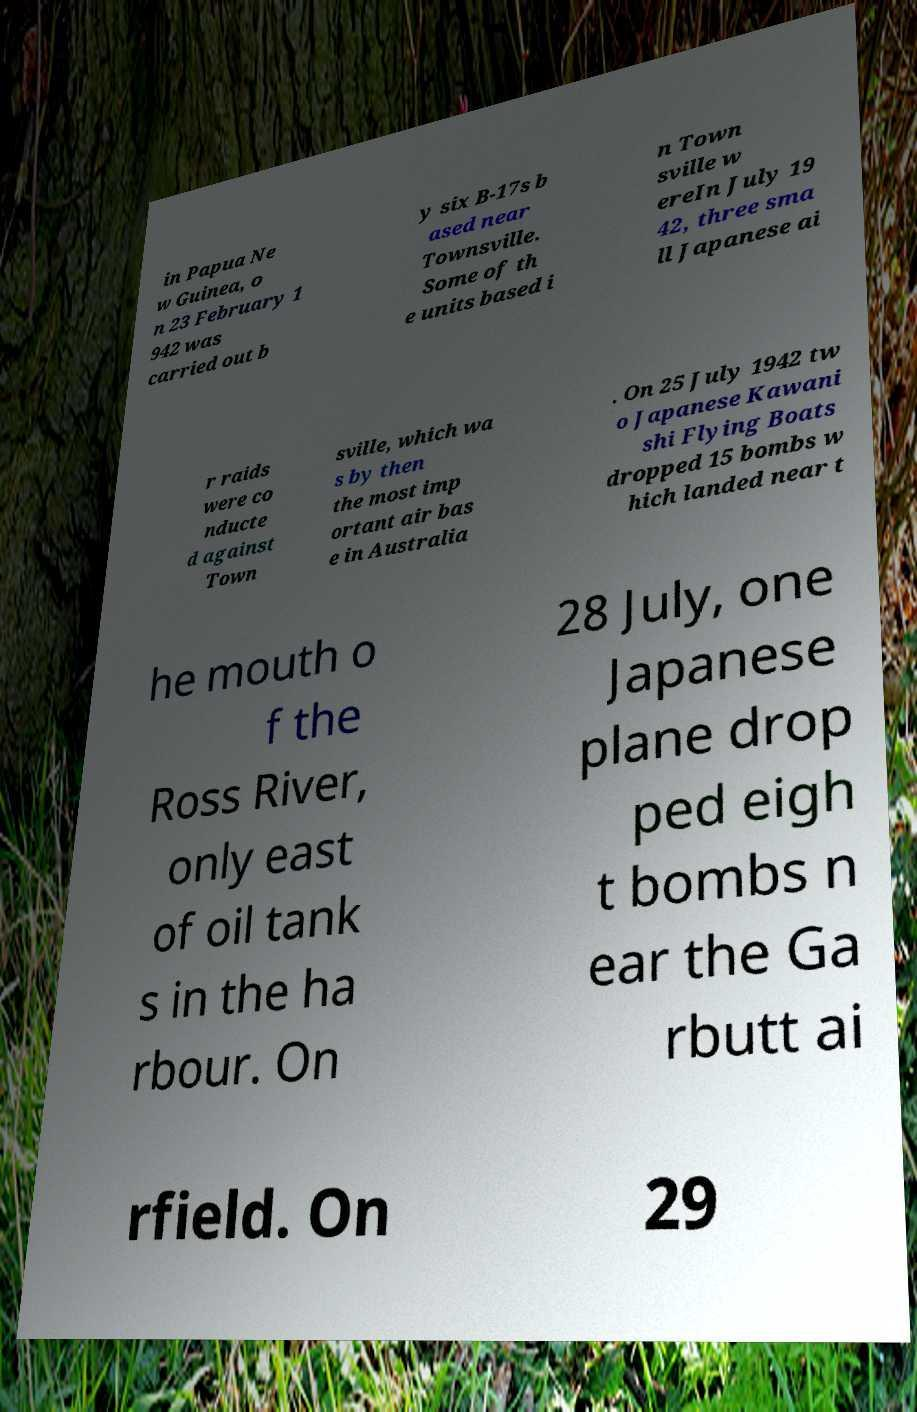Please identify and transcribe the text found in this image. in Papua Ne w Guinea, o n 23 February 1 942 was carried out b y six B-17s b ased near Townsville. Some of th e units based i n Town sville w ereIn July 19 42, three sma ll Japanese ai r raids were co nducte d against Town sville, which wa s by then the most imp ortant air bas e in Australia . On 25 July 1942 tw o Japanese Kawani shi Flying Boats dropped 15 bombs w hich landed near t he mouth o f the Ross River, only east of oil tank s in the ha rbour. On 28 July, one Japanese plane drop ped eigh t bombs n ear the Ga rbutt ai rfield. On 29 